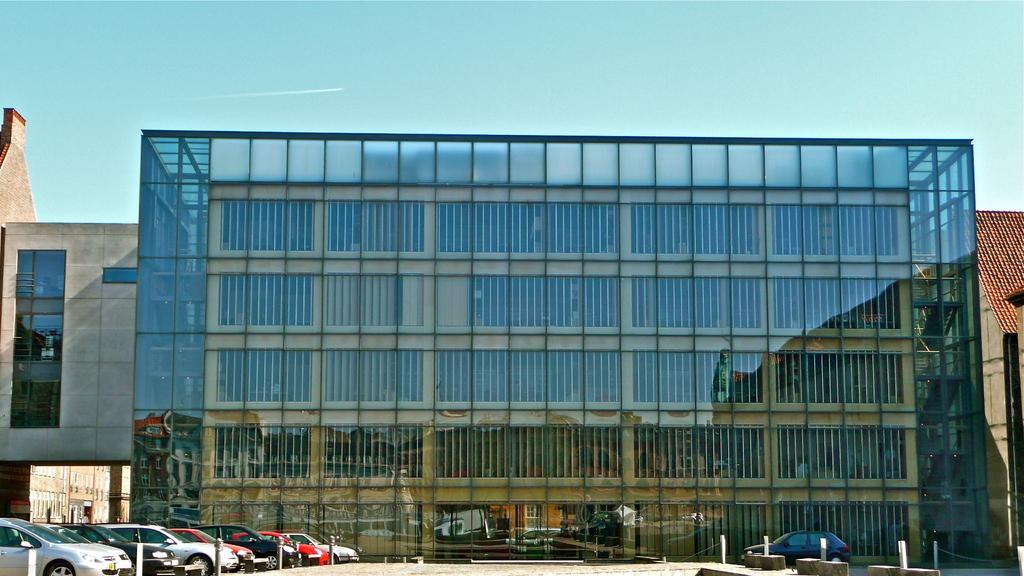What type of vehicles are present in the image? There are cars in the image. Where are the cars located in relation to other objects? The cars are in front of a building. What can be seen at the top of the image? The sky is visible at the top of the image. What type of yarn is being used to decorate the cars in the image? There is no yarn present in the image, and the cars are not being decorated with any yarn. 